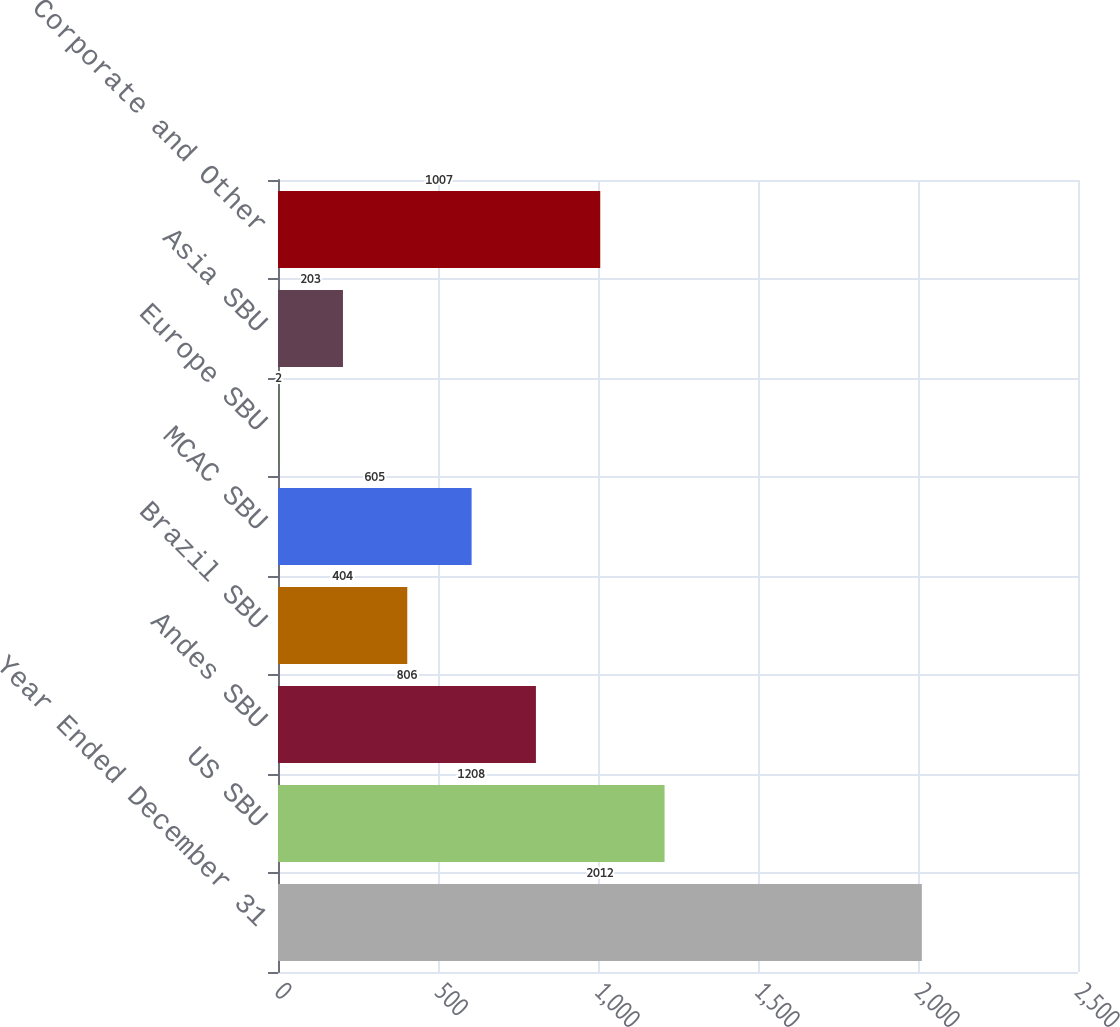Convert chart. <chart><loc_0><loc_0><loc_500><loc_500><bar_chart><fcel>Year Ended December 31<fcel>US SBU<fcel>Andes SBU<fcel>Brazil SBU<fcel>MCAC SBU<fcel>Europe SBU<fcel>Asia SBU<fcel>Corporate and Other<nl><fcel>2012<fcel>1208<fcel>806<fcel>404<fcel>605<fcel>2<fcel>203<fcel>1007<nl></chart> 